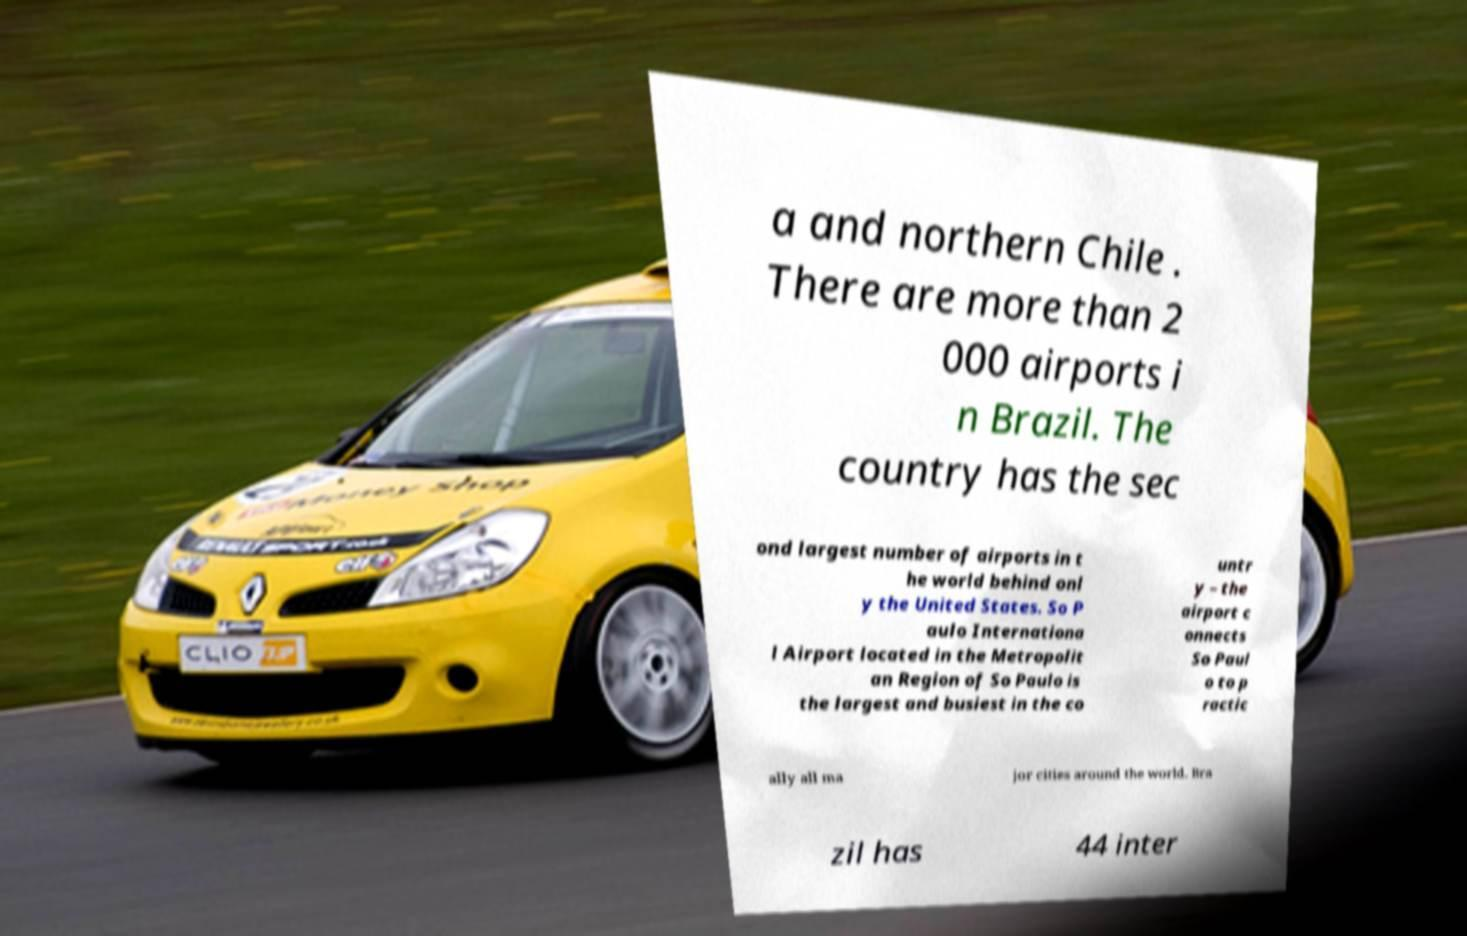Please identify and transcribe the text found in this image. a and northern Chile . There are more than 2 000 airports i n Brazil. The country has the sec ond largest number of airports in t he world behind onl y the United States. So P aulo Internationa l Airport located in the Metropolit an Region of So Paulo is the largest and busiest in the co untr y – the airport c onnects So Paul o to p ractic ally all ma jor cities around the world. Bra zil has 44 inter 